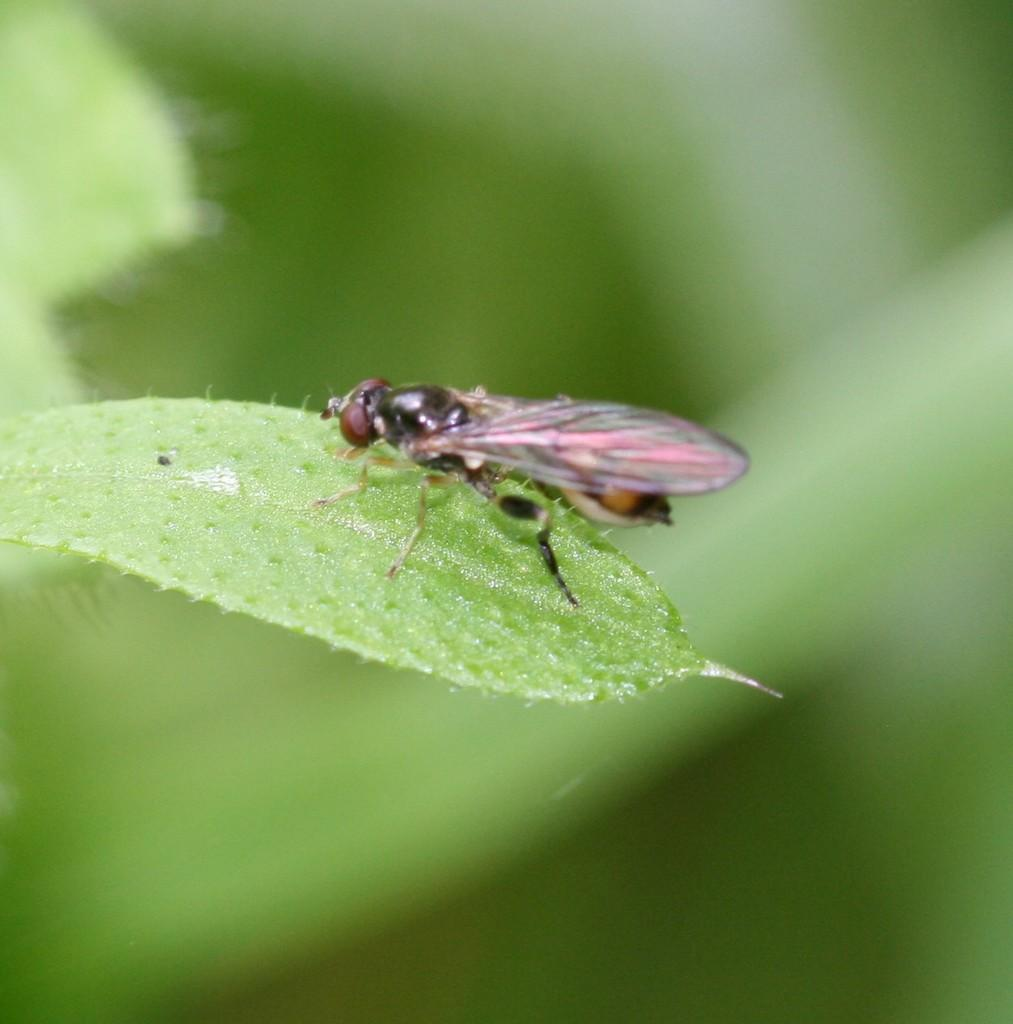What is present in the image? There is an insect in the image. Where is the insect located? The insect is on a leaf. What type of zipper can be seen on the insect in the image? There is no zipper present on the insect in the image. 